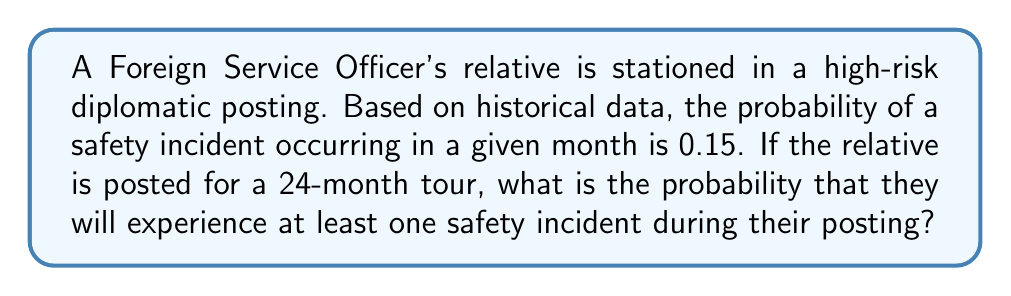Provide a solution to this math problem. To solve this problem, we'll use the complement rule of probability:

1) Let's define the event A as "experiencing at least one safety incident during the 24-month tour".

2) The probability we're looking for is P(A).

3) It's easier to calculate the probability of the complement of A, which is "experiencing no safety incidents during the 24-month tour". Let's call this event B.

4) For each month, the probability of no incident is 1 - 0.15 = 0.85.

5) For the entire 24-month period, we need all 24 months to be incident-free. This is calculated by multiplying the probability of a safe month 24 times:

   P(B) = $0.85^{24}$

6) Now, we can use the complement rule:

   P(A) = 1 - P(B) = 1 - $0.85^{24}$

7) Calculate:
   $0.85^{24} \approx 0.0214$

8) Therefore:
   P(A) = 1 - 0.0214 = 0.9786

9) Convert to percentage:
   0.9786 * 100% = 97.86%
Answer: 97.86% 